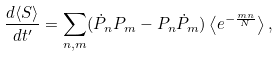Convert formula to latex. <formula><loc_0><loc_0><loc_500><loc_500>\frac { d \langle S \rangle } { d t ^ { \prime } } = \sum _ { n , m } ( \dot { P } _ { n } P _ { m } - P _ { n } \dot { P } _ { m } ) \left \langle e ^ { - \frac { m n } { N } } \right \rangle ,</formula> 